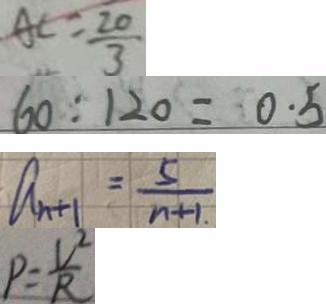Convert formula to latex. <formula><loc_0><loc_0><loc_500><loc_500>A C = \frac { 2 0 } { 3 } 
 6 0 : 1 2 0 = 0 . 5 
 a _ { n + 1 } = \frac { 5 } { n + 1 } 
 P = \frac { V ^ { 2 } } { R }</formula> 